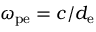<formula> <loc_0><loc_0><loc_500><loc_500>\omega _ { p e } = c / d _ { e }</formula> 